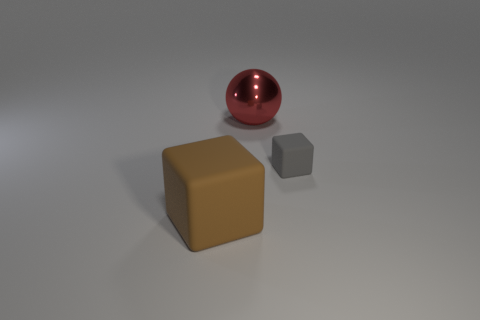Is there anything else that has the same size as the gray matte cube?
Offer a terse response. No. Does the block in front of the small rubber block have the same size as the red thing that is behind the tiny object?
Your answer should be compact. Yes. How many small gray objects are the same shape as the brown matte object?
Provide a short and direct response. 1. There is a thing that is behind the rubber cube behind the rubber cube that is in front of the tiny gray rubber cube; what is it made of?
Offer a terse response. Metal. Do the shiny ball and the cube behind the big rubber thing have the same size?
Your answer should be compact. No. There is another thing that is the same shape as the big rubber object; what material is it?
Your response must be concise. Rubber. How big is the rubber block on the right side of the large object behind the big thing in front of the shiny ball?
Offer a terse response. Small. Do the red metal ball and the brown matte block have the same size?
Keep it short and to the point. Yes. What material is the thing in front of the block to the right of the shiny ball made of?
Make the answer very short. Rubber. Do the rubber thing that is to the right of the brown block and the thing in front of the gray rubber object have the same shape?
Offer a terse response. Yes. 